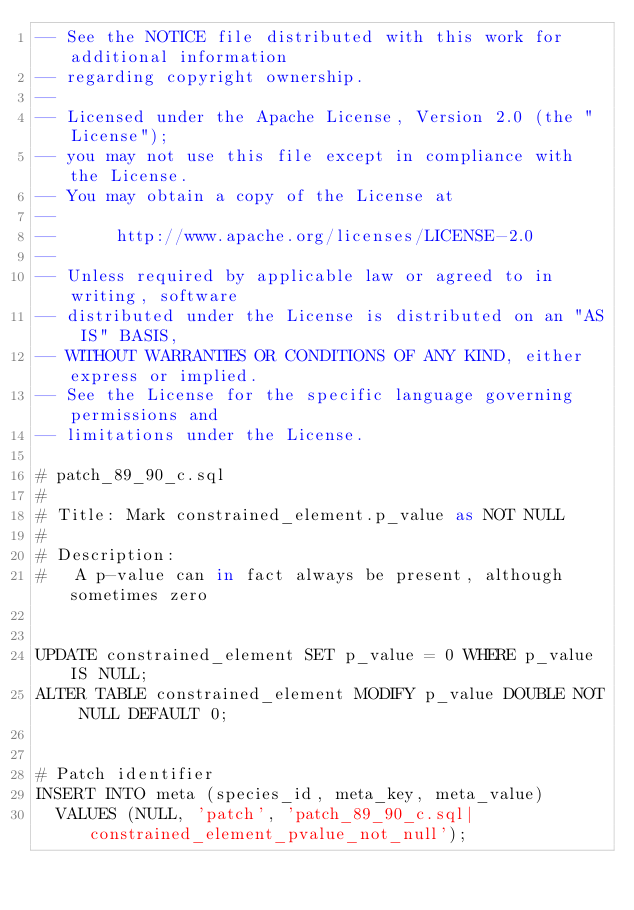<code> <loc_0><loc_0><loc_500><loc_500><_SQL_>-- See the NOTICE file distributed with this work for additional information
-- regarding copyright ownership.
-- 
-- Licensed under the Apache License, Version 2.0 (the "License");
-- you may not use this file except in compliance with the License.
-- You may obtain a copy of the License at
-- 
--      http://www.apache.org/licenses/LICENSE-2.0
-- 
-- Unless required by applicable law or agreed to in writing, software
-- distributed under the License is distributed on an "AS IS" BASIS,
-- WITHOUT WARRANTIES OR CONDITIONS OF ANY KIND, either express or implied.
-- See the License for the specific language governing permissions and
-- limitations under the License.

# patch_89_90_c.sql
#
# Title: Mark constrained_element.p_value as NOT NULL
#
# Description:
#   A p-value can in fact always be present, although sometimes zero


UPDATE constrained_element SET p_value = 0 WHERE p_value IS NULL;
ALTER TABLE constrained_element MODIFY p_value DOUBLE NOT NULL DEFAULT 0;


# Patch identifier
INSERT INTO meta (species_id, meta_key, meta_value)
  VALUES (NULL, 'patch', 'patch_89_90_c.sql|constrained_element_pvalue_not_null');
</code> 